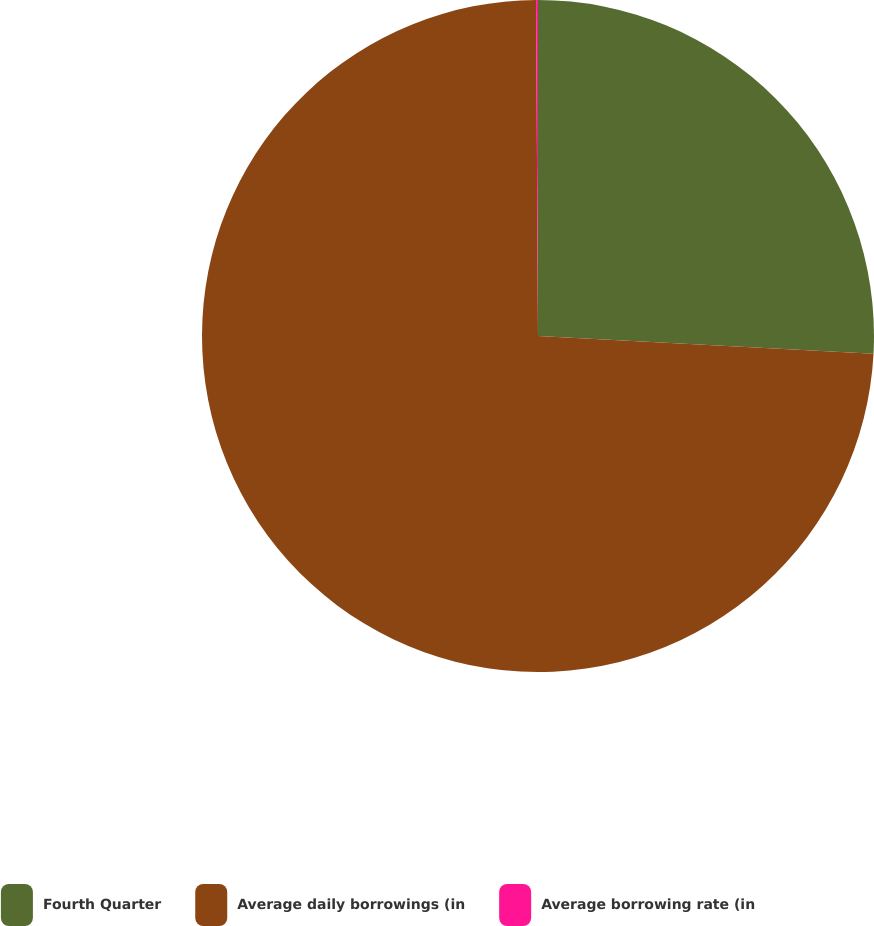Convert chart to OTSL. <chart><loc_0><loc_0><loc_500><loc_500><pie_chart><fcel>Fourth Quarter<fcel>Average daily borrowings (in<fcel>Average borrowing rate (in<nl><fcel>25.84%<fcel>74.07%<fcel>0.09%<nl></chart> 